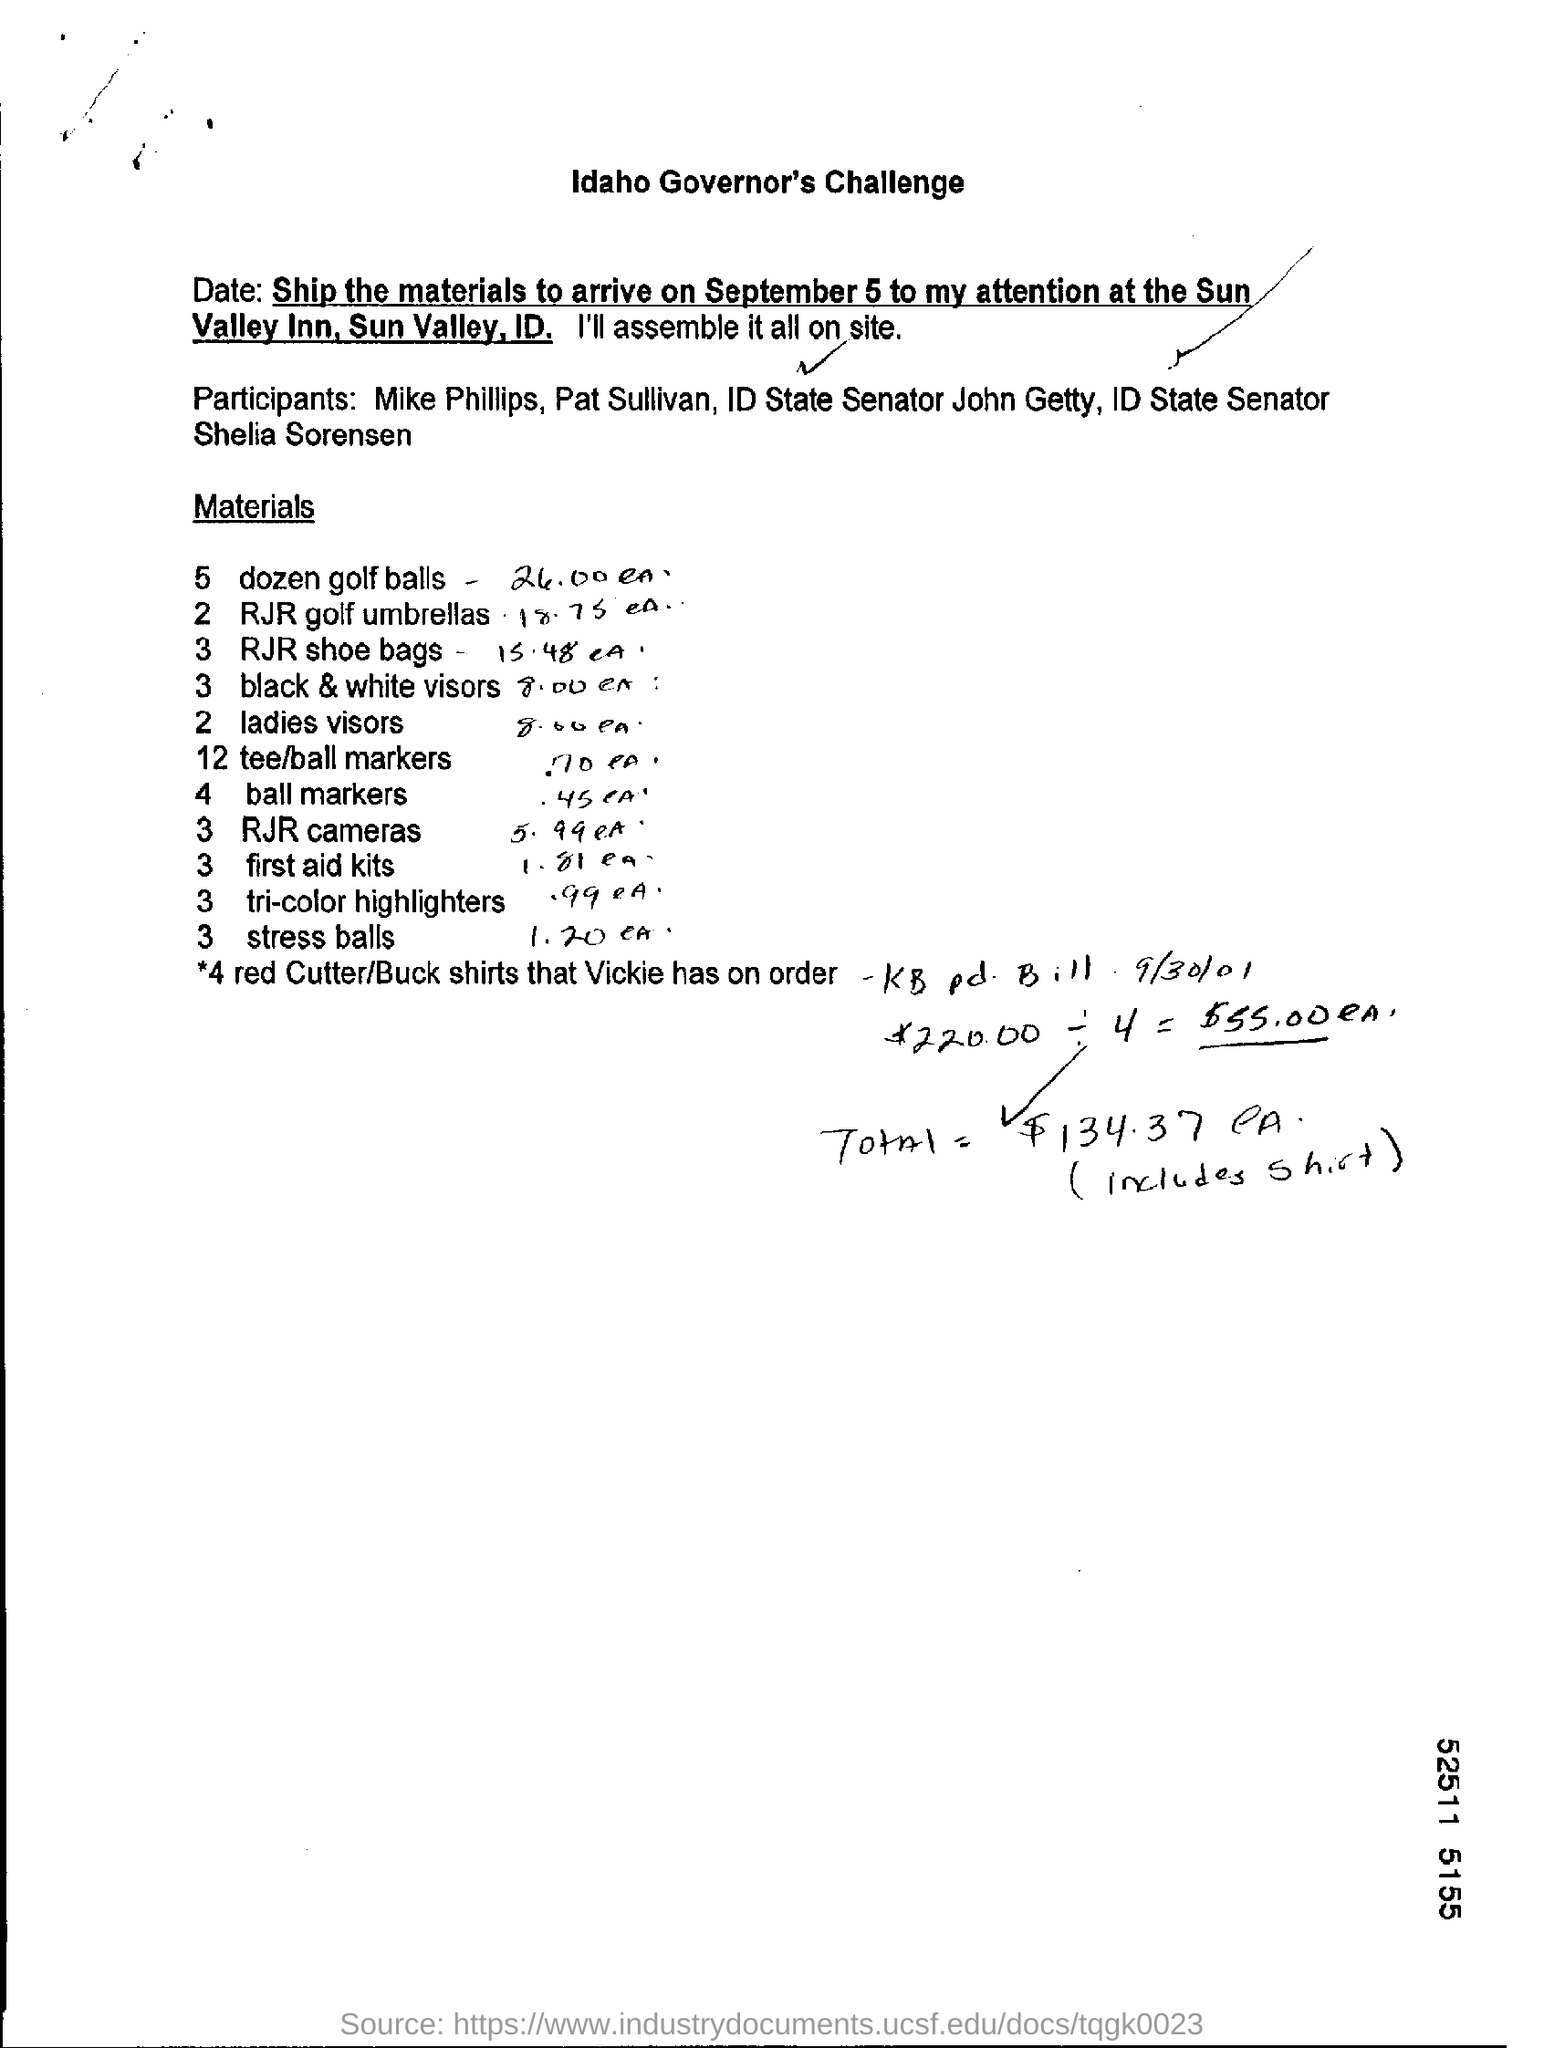Ship the materials to arrive when?
Give a very brief answer. September 5. How many dozen golf balls?
Offer a terse response. 5. How many black and white visors?
Provide a succinct answer. 3. How many RJR Golf umbrellas?
Provide a succinct answer. 2. How many RJR Shoe bags?
Make the answer very short. 3. How many ladies visors?
Your answer should be compact. 2. How many first aid kits?
Your response must be concise. 3. 